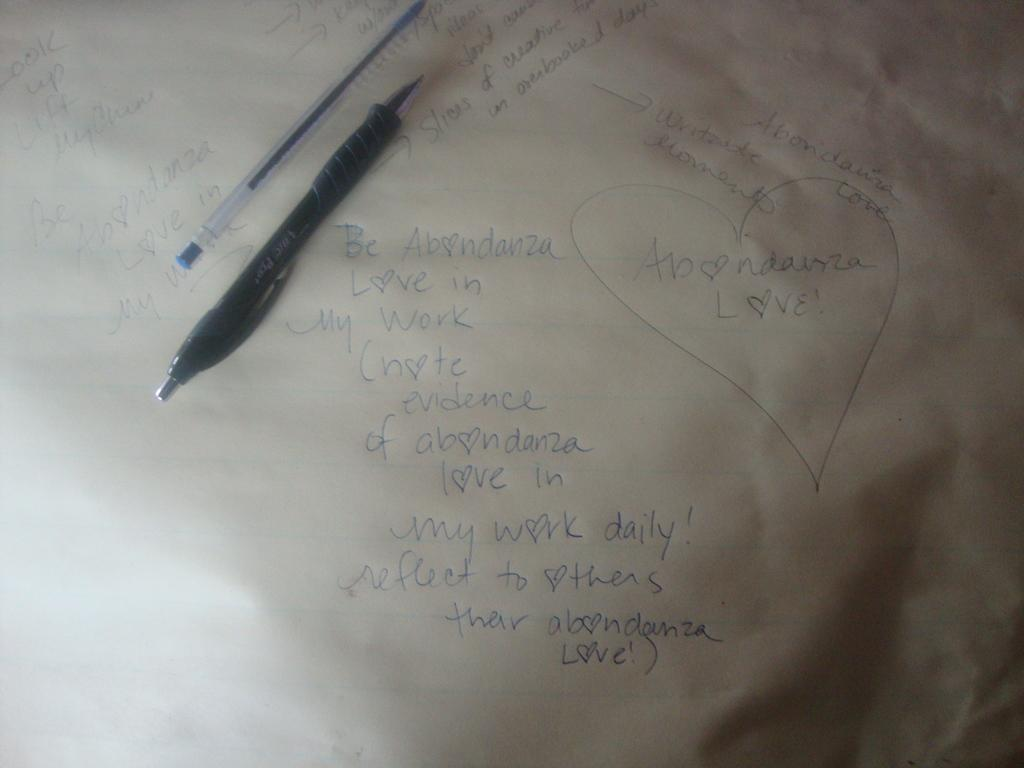What is present on the paper in the image? There are two pens on the paper. What else can be seen on the paper? There is text written on the paper. How many pens are visible on the paper? There are two pens visible on the paper. What type of flowers are growing on the paper in the image? There are no flowers present on the paper in the image. 